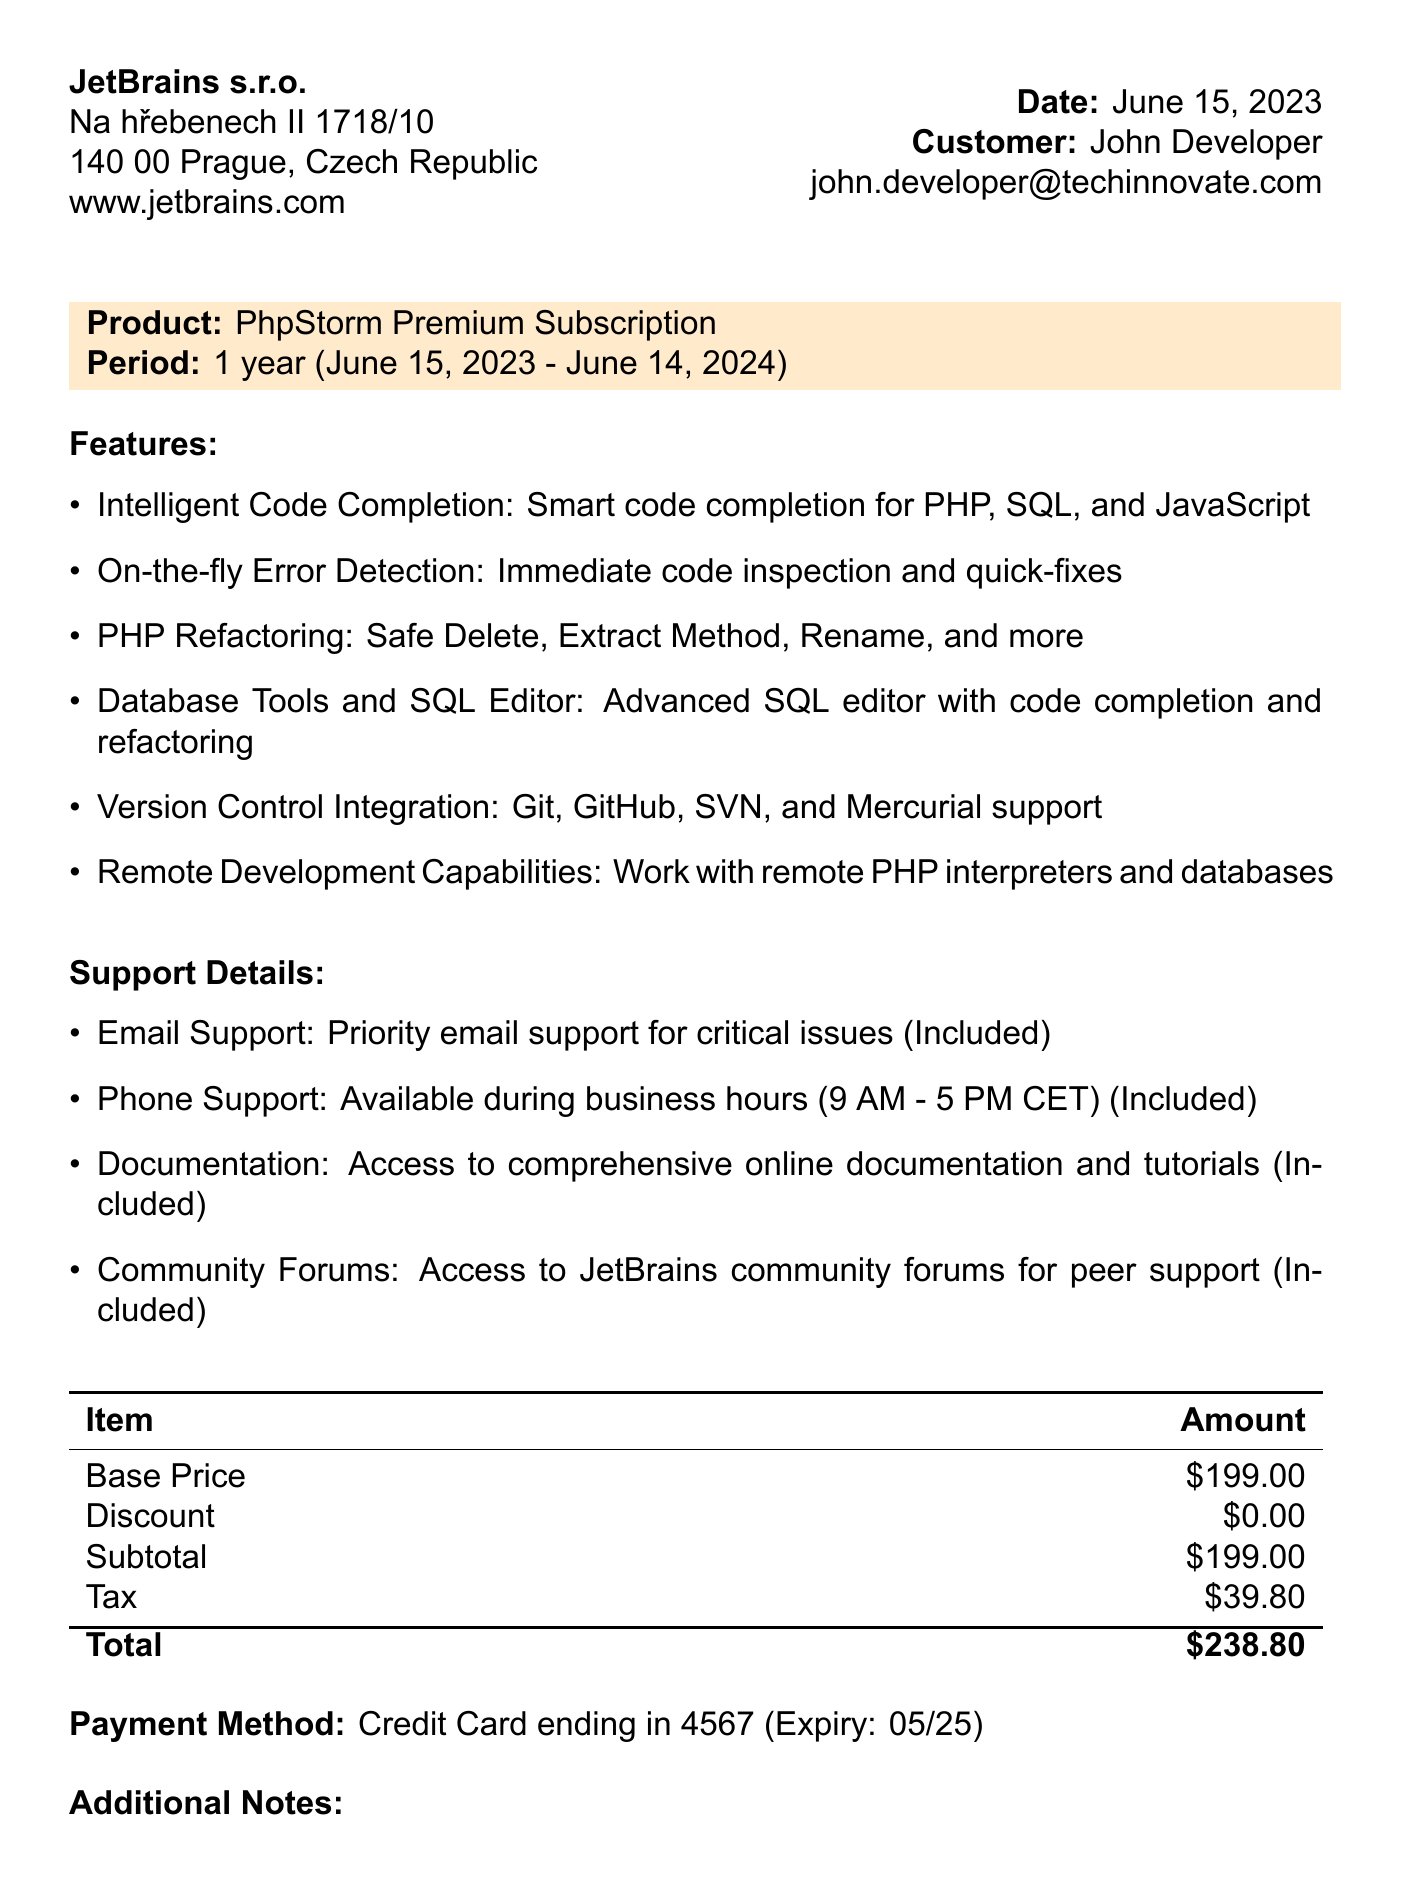What is the receipt number? The receipt number is listed at the top of the document as INV-2023-05678.
Answer: INV-2023-05678 What is the total amount of the subscription? The total amount is calculated at the bottom of the pricing section as $238.80.
Answer: $238.80 Who is the customer? The customer's name is mentioned in the document as John Developer.
Answer: John Developer What is the subscription period? The subscription period is clearly stated in the product section as 1 year.
Answer: 1 year What features include remote development capabilities? The features list mentions remote development capabilities as one of the key features of the subscription.
Answer: Remote Development Capabilities What payment method was used? The payment method is specified in the payment section as Credit Card.
Answer: Credit Card When does the subscription end? The end date of the subscription is noted as June 14, 2024.
Answer: June 14, 2024 Is phone support included? The support details section confirms that phone support is included in the subscription.
Answer: Included What company issued the receipt? The company name at the top of the document is JetBrains s.r.o.
Answer: JetBrains s.r.o 